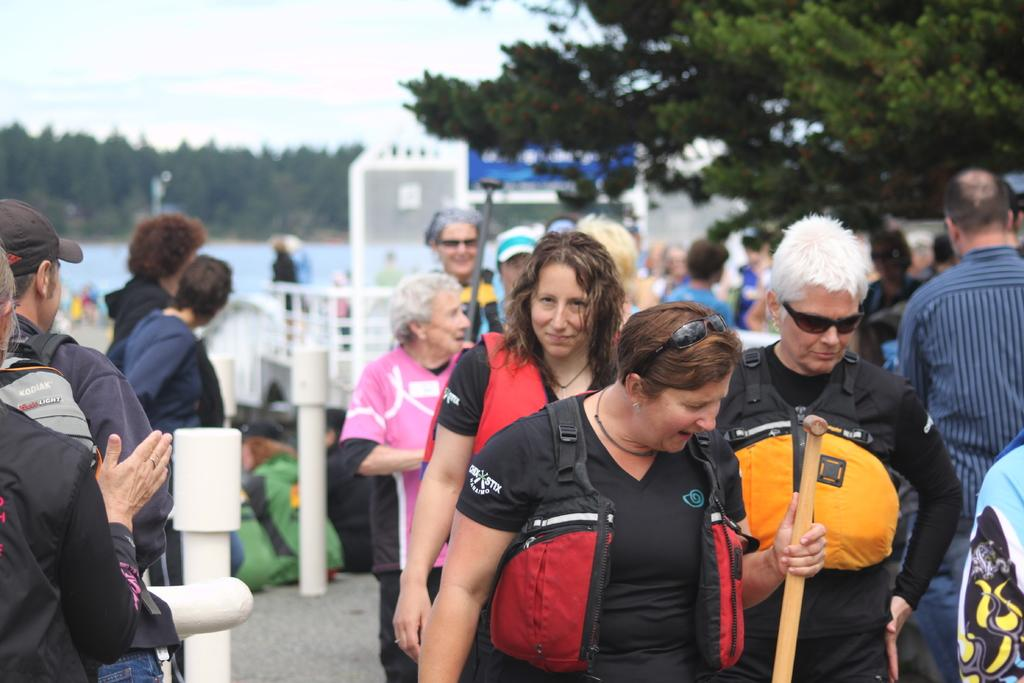What is the main subject of the image? The main subject of the image is a crowd. Can you describe the background of the image? The background of the image is blurry. What can be seen in the background of the image? Trees are visible in the background. What is the woman in the image holding? The woman is holding a stick in the image. What team is the woman supporting in the image? There is no indication of a team or any sports event in the image, so it cannot be determined from the image. 